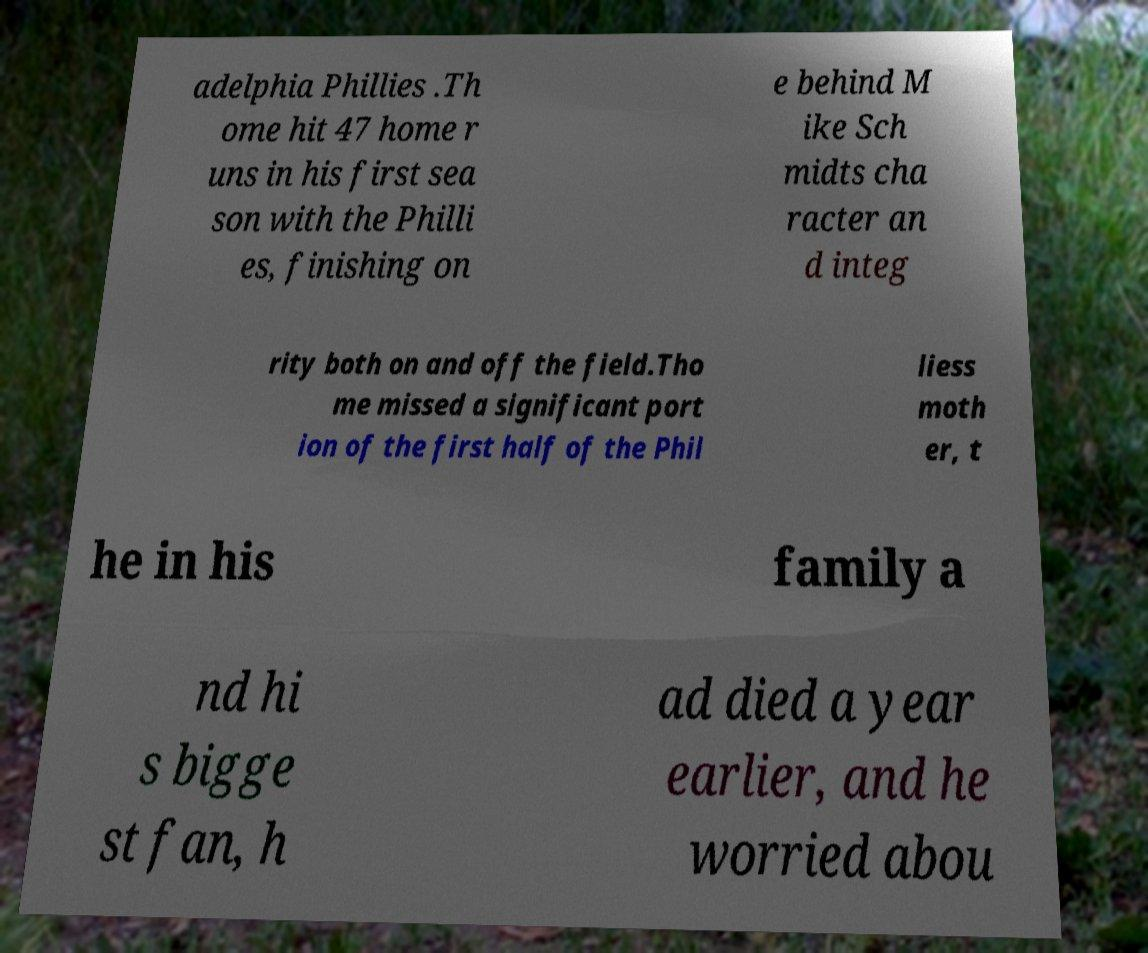Could you assist in decoding the text presented in this image and type it out clearly? adelphia Phillies .Th ome hit 47 home r uns in his first sea son with the Philli es, finishing on e behind M ike Sch midts cha racter an d integ rity both on and off the field.Tho me missed a significant port ion of the first half of the Phil liess moth er, t he in his family a nd hi s bigge st fan, h ad died a year earlier, and he worried abou 